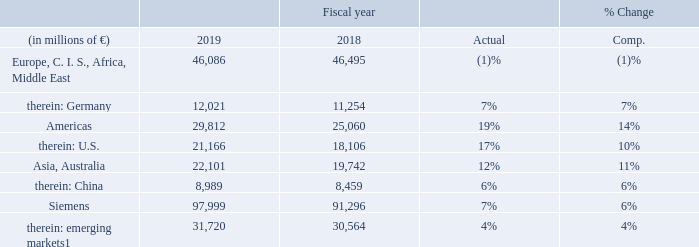A.4.1 Orders and revenue by region
Positive currency translation effects added one percentage point each to order and revenue growth; portfolio transactions had only minimal effects on volume growth year-over-year. The resulting ratio of orders to revenue (book-to-bill) for Siemens in fiscal 2019 was a strong 1.13, again well above 1. The order backlog was € 146 billion as of September 30, 2019, a new high.
1 As defined by the International Monetary Fund.
Orders related to external customers were clearly up year-overyear on growth in nearly all industrial businesses, led by Mobility. Gas and Power, Siemens Healthineers, Smart Infrastructure and SGRE all posted clear growth, while orders declined slightly in Digital Industries. Volume from large orders for Industrial Businesses overall was up substantially due to a sharp increase at Mobility, but also due to a significant increase in SGRE and Gas and Power. Growth in emerging markets was driven by orders from China, and from Russia where Mobility won a € 1.2 billion contract for high-speed trains including maintenance.
Order development was mixed in the Europe, C. I. S., Africa, Middle East region. The majority of industrial businesses posted order growth, led by double-digit growth in Mobility, which won several large contracts in the year under review. This increase was more than offset by a substantial decline in SGRE due mainly to a lower volume from large orders and a decrease in Digital Industries. In contrast to the region overall, orders were up clearly in Germany, driven by sharp growth in Gas and Power which recorded, among others, a large high voltage direct current (HVDC) order. Mobility recorded a significant increase in order intake in Germany, while the other industrial businesses posted declines.
Orders in the Americas region were up significantly year-over-year, benefiting from positive currency translation effects. Double-digit growth in nearly all industrial businesses was led by SGRE and Mobility with particularly sharp increases. The pattern of order development in the U. S. was largely the same as in the Americas region.
In the Asia, Australia region, orders also rose significantly due to growth in nearly all industrial businesses. The primary growth driver was SGRE, which recorded a sharply higher volume from large orders, including two large orders for offshore wind-farms
including service in Taiwan totaling € 2.3 billion. Orders for Mobility dropped substantially compared to the prior year. Clear growth in China included a majority of industrial businesses.
How has the Positive currency translation affected the revenue? Positive currency translation effects added one percentage point each to order and revenue growth; portfolio transactions had only minimal effects on volume growth year-over-year. What drove the growth in the emerging markets? Growth in emerging markets was driven by orders from china, and from russia where mobility won a € 1.2 billion contract for high-speed trains including maintenance. What drove the increase in the orders in the Americas region? Orders in the americas region were up significantly year-over-year, benefiting from positive currency translation effects. double-digit growth in nearly all industrial businesses was led by sgre and mobility with particularly sharp increases. the pattern of order development in the u. s. was largely the same as in the americas region. What was the average orders in the Americas region in 2019 and 2018?
Answer scale should be: million. (29,812 + 25,060) / 2
Answer: 27436. What is the increase / (decrease) in the orders for Asia and Australia from 2018 to 2019?
Answer scale should be: million. 22,101 - 19,742
Answer: 2359. What is the percentage increase in the orders for Siemens from 2019 to 2018?
Answer scale should be: percent. 97,999 / 91,296 - 1
Answer: 7.34. 